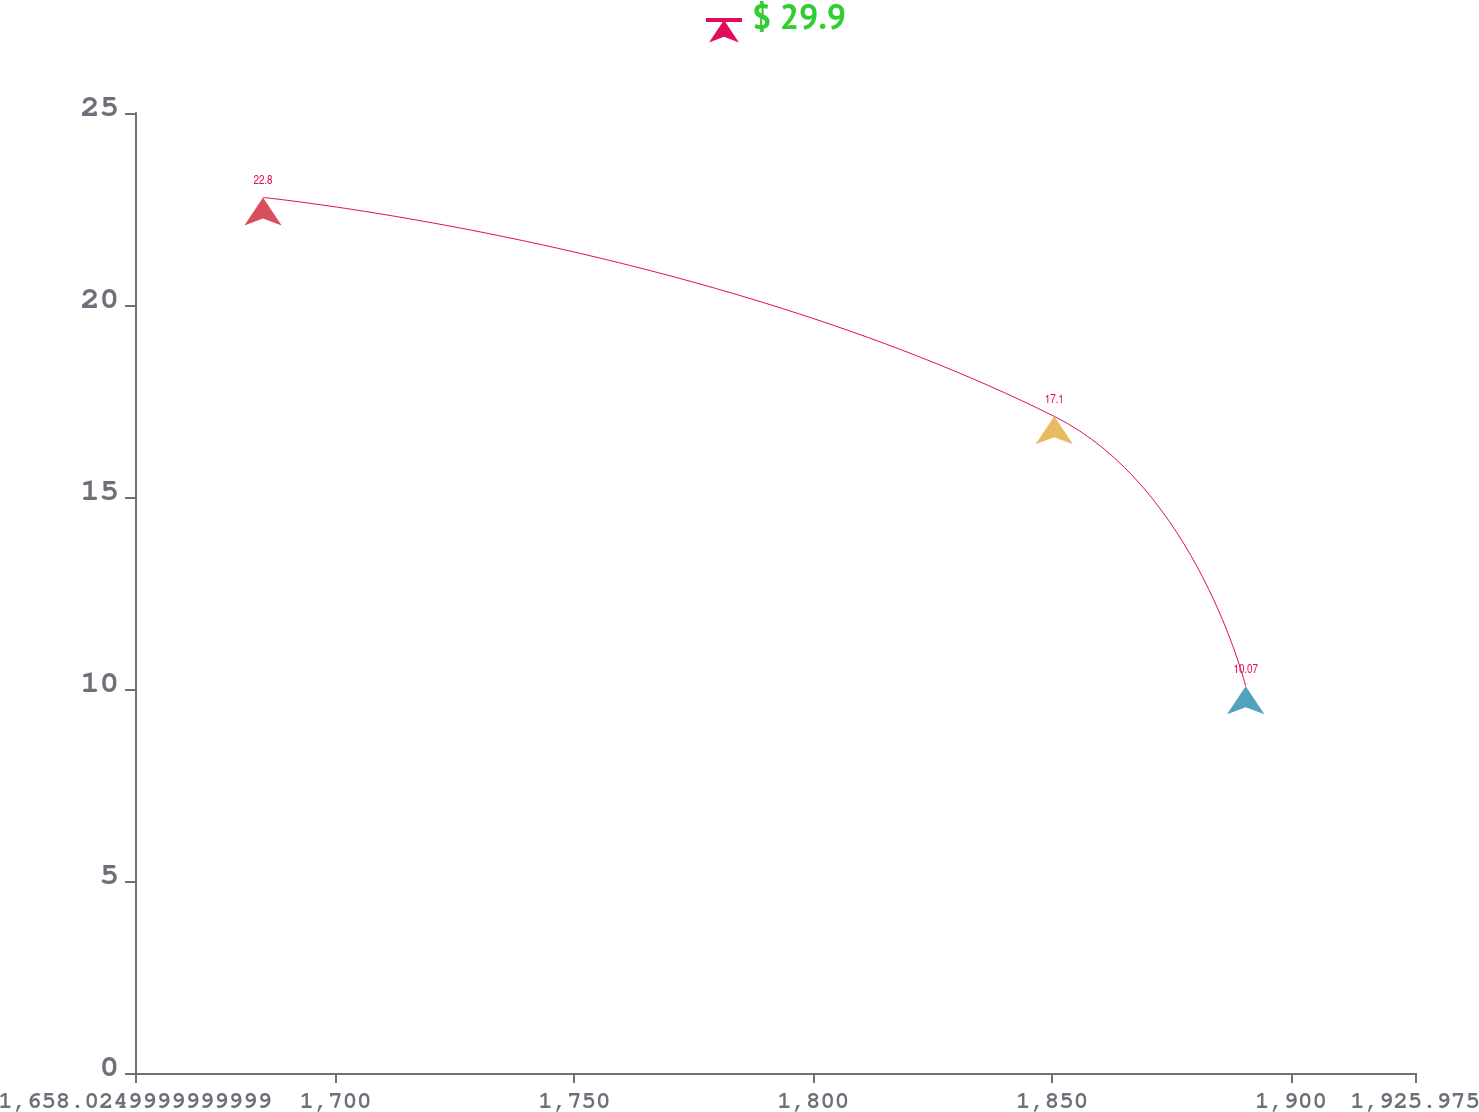Convert chart to OTSL. <chart><loc_0><loc_0><loc_500><loc_500><line_chart><ecel><fcel>$ 29.9<nl><fcel>1684.82<fcel>22.8<nl><fcel>1850.46<fcel>17.1<nl><fcel>1890.54<fcel>10.07<nl><fcel>1952.77<fcel>11.36<nl></chart> 